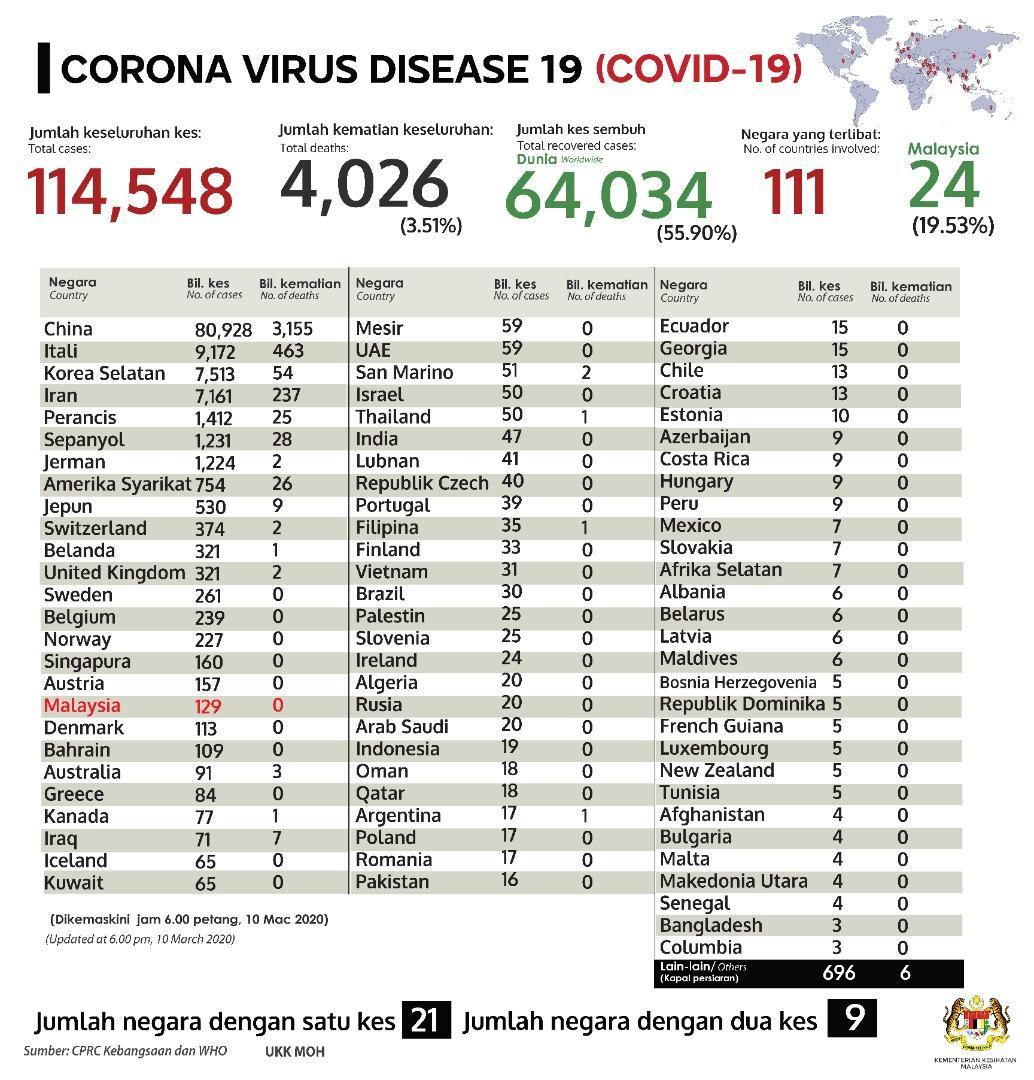What is the difference between the number of cases and number of deaths in Iraq?
Answer the question with a short phrase. 64 What is the difference between total cases and total recovered cases? 50,514 What is the difference between total recovered cases and total deaths in percentage? 52.39% What is the difference between number of cases and number of deaths in Thailand? 49 What is the difference between total cases and total deaths? 110,522 